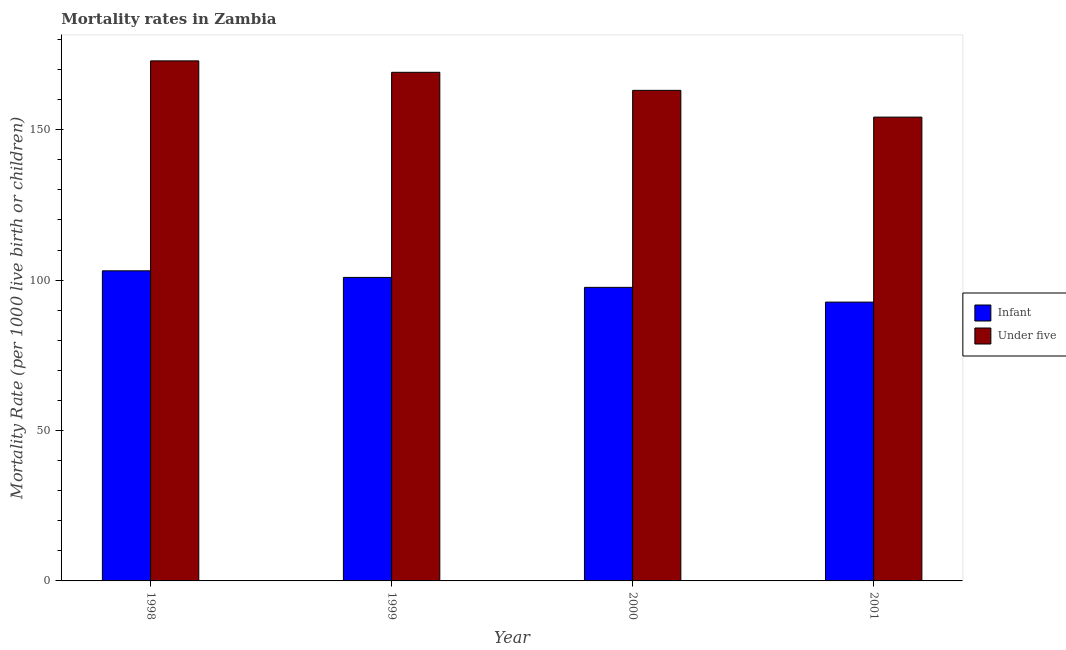How many different coloured bars are there?
Offer a very short reply. 2. Are the number of bars per tick equal to the number of legend labels?
Your answer should be compact. Yes. Are the number of bars on each tick of the X-axis equal?
Provide a short and direct response. Yes. How many bars are there on the 3rd tick from the right?
Provide a succinct answer. 2. What is the label of the 1st group of bars from the left?
Your response must be concise. 1998. In how many cases, is the number of bars for a given year not equal to the number of legend labels?
Keep it short and to the point. 0. What is the infant mortality rate in 2001?
Your answer should be very brief. 92.7. Across all years, what is the maximum infant mortality rate?
Your answer should be compact. 103.1. Across all years, what is the minimum under-5 mortality rate?
Offer a terse response. 154.2. In which year was the under-5 mortality rate maximum?
Your response must be concise. 1998. In which year was the under-5 mortality rate minimum?
Your response must be concise. 2001. What is the total under-5 mortality rate in the graph?
Provide a succinct answer. 659.3. What is the difference between the infant mortality rate in 1998 and that in 2001?
Ensure brevity in your answer.  10.4. What is the difference between the infant mortality rate in 2000 and the under-5 mortality rate in 2001?
Provide a succinct answer. 4.9. What is the average under-5 mortality rate per year?
Offer a very short reply. 164.82. In how many years, is the infant mortality rate greater than 10?
Your answer should be very brief. 4. What is the ratio of the under-5 mortality rate in 1999 to that in 2001?
Your answer should be compact. 1.1. Is the under-5 mortality rate in 1998 less than that in 2001?
Your answer should be compact. No. What is the difference between the highest and the second highest infant mortality rate?
Your answer should be very brief. 2.2. What is the difference between the highest and the lowest infant mortality rate?
Offer a terse response. 10.4. Is the sum of the infant mortality rate in 1999 and 2000 greater than the maximum under-5 mortality rate across all years?
Give a very brief answer. Yes. What does the 2nd bar from the left in 1998 represents?
Offer a very short reply. Under five. What does the 1st bar from the right in 2000 represents?
Give a very brief answer. Under five. How many bars are there?
Your response must be concise. 8. Are all the bars in the graph horizontal?
Keep it short and to the point. No. What is the difference between two consecutive major ticks on the Y-axis?
Your answer should be compact. 50. Does the graph contain any zero values?
Ensure brevity in your answer.  No. Where does the legend appear in the graph?
Your response must be concise. Center right. What is the title of the graph?
Give a very brief answer. Mortality rates in Zambia. Does "Domestic liabilities" appear as one of the legend labels in the graph?
Offer a very short reply. No. What is the label or title of the Y-axis?
Provide a short and direct response. Mortality Rate (per 1000 live birth or children). What is the Mortality Rate (per 1000 live birth or children) of Infant in 1998?
Provide a short and direct response. 103.1. What is the Mortality Rate (per 1000 live birth or children) in Under five in 1998?
Make the answer very short. 172.9. What is the Mortality Rate (per 1000 live birth or children) of Infant in 1999?
Your answer should be very brief. 100.9. What is the Mortality Rate (per 1000 live birth or children) of Under five in 1999?
Give a very brief answer. 169.1. What is the Mortality Rate (per 1000 live birth or children) in Infant in 2000?
Give a very brief answer. 97.6. What is the Mortality Rate (per 1000 live birth or children) of Under five in 2000?
Keep it short and to the point. 163.1. What is the Mortality Rate (per 1000 live birth or children) in Infant in 2001?
Your answer should be compact. 92.7. What is the Mortality Rate (per 1000 live birth or children) in Under five in 2001?
Make the answer very short. 154.2. Across all years, what is the maximum Mortality Rate (per 1000 live birth or children) of Infant?
Your answer should be very brief. 103.1. Across all years, what is the maximum Mortality Rate (per 1000 live birth or children) in Under five?
Ensure brevity in your answer.  172.9. Across all years, what is the minimum Mortality Rate (per 1000 live birth or children) of Infant?
Offer a terse response. 92.7. Across all years, what is the minimum Mortality Rate (per 1000 live birth or children) in Under five?
Offer a very short reply. 154.2. What is the total Mortality Rate (per 1000 live birth or children) of Infant in the graph?
Ensure brevity in your answer.  394.3. What is the total Mortality Rate (per 1000 live birth or children) of Under five in the graph?
Ensure brevity in your answer.  659.3. What is the difference between the Mortality Rate (per 1000 live birth or children) in Infant in 1998 and that in 1999?
Keep it short and to the point. 2.2. What is the difference between the Mortality Rate (per 1000 live birth or children) in Infant in 1998 and that in 2001?
Keep it short and to the point. 10.4. What is the difference between the Mortality Rate (per 1000 live birth or children) of Infant in 1999 and that in 2000?
Your response must be concise. 3.3. What is the difference between the Mortality Rate (per 1000 live birth or children) of Infant in 2000 and that in 2001?
Give a very brief answer. 4.9. What is the difference between the Mortality Rate (per 1000 live birth or children) in Under five in 2000 and that in 2001?
Offer a terse response. 8.9. What is the difference between the Mortality Rate (per 1000 live birth or children) of Infant in 1998 and the Mortality Rate (per 1000 live birth or children) of Under five in 1999?
Keep it short and to the point. -66. What is the difference between the Mortality Rate (per 1000 live birth or children) of Infant in 1998 and the Mortality Rate (per 1000 live birth or children) of Under five in 2000?
Provide a succinct answer. -60. What is the difference between the Mortality Rate (per 1000 live birth or children) of Infant in 1998 and the Mortality Rate (per 1000 live birth or children) of Under five in 2001?
Provide a succinct answer. -51.1. What is the difference between the Mortality Rate (per 1000 live birth or children) of Infant in 1999 and the Mortality Rate (per 1000 live birth or children) of Under five in 2000?
Ensure brevity in your answer.  -62.2. What is the difference between the Mortality Rate (per 1000 live birth or children) in Infant in 1999 and the Mortality Rate (per 1000 live birth or children) in Under five in 2001?
Your answer should be very brief. -53.3. What is the difference between the Mortality Rate (per 1000 live birth or children) of Infant in 2000 and the Mortality Rate (per 1000 live birth or children) of Under five in 2001?
Your response must be concise. -56.6. What is the average Mortality Rate (per 1000 live birth or children) of Infant per year?
Keep it short and to the point. 98.58. What is the average Mortality Rate (per 1000 live birth or children) in Under five per year?
Your response must be concise. 164.82. In the year 1998, what is the difference between the Mortality Rate (per 1000 live birth or children) of Infant and Mortality Rate (per 1000 live birth or children) of Under five?
Your answer should be very brief. -69.8. In the year 1999, what is the difference between the Mortality Rate (per 1000 live birth or children) of Infant and Mortality Rate (per 1000 live birth or children) of Under five?
Make the answer very short. -68.2. In the year 2000, what is the difference between the Mortality Rate (per 1000 live birth or children) in Infant and Mortality Rate (per 1000 live birth or children) in Under five?
Keep it short and to the point. -65.5. In the year 2001, what is the difference between the Mortality Rate (per 1000 live birth or children) in Infant and Mortality Rate (per 1000 live birth or children) in Under five?
Your answer should be very brief. -61.5. What is the ratio of the Mortality Rate (per 1000 live birth or children) of Infant in 1998 to that in 1999?
Provide a short and direct response. 1.02. What is the ratio of the Mortality Rate (per 1000 live birth or children) of Under five in 1998 to that in 1999?
Make the answer very short. 1.02. What is the ratio of the Mortality Rate (per 1000 live birth or children) of Infant in 1998 to that in 2000?
Offer a terse response. 1.06. What is the ratio of the Mortality Rate (per 1000 live birth or children) in Under five in 1998 to that in 2000?
Provide a short and direct response. 1.06. What is the ratio of the Mortality Rate (per 1000 live birth or children) in Infant in 1998 to that in 2001?
Make the answer very short. 1.11. What is the ratio of the Mortality Rate (per 1000 live birth or children) of Under five in 1998 to that in 2001?
Keep it short and to the point. 1.12. What is the ratio of the Mortality Rate (per 1000 live birth or children) of Infant in 1999 to that in 2000?
Make the answer very short. 1.03. What is the ratio of the Mortality Rate (per 1000 live birth or children) in Under five in 1999 to that in 2000?
Your answer should be very brief. 1.04. What is the ratio of the Mortality Rate (per 1000 live birth or children) in Infant in 1999 to that in 2001?
Provide a succinct answer. 1.09. What is the ratio of the Mortality Rate (per 1000 live birth or children) in Under five in 1999 to that in 2001?
Provide a short and direct response. 1.1. What is the ratio of the Mortality Rate (per 1000 live birth or children) in Infant in 2000 to that in 2001?
Ensure brevity in your answer.  1.05. What is the ratio of the Mortality Rate (per 1000 live birth or children) in Under five in 2000 to that in 2001?
Your answer should be compact. 1.06. What is the difference between the highest and the second highest Mortality Rate (per 1000 live birth or children) of Under five?
Offer a very short reply. 3.8. What is the difference between the highest and the lowest Mortality Rate (per 1000 live birth or children) of Under five?
Give a very brief answer. 18.7. 